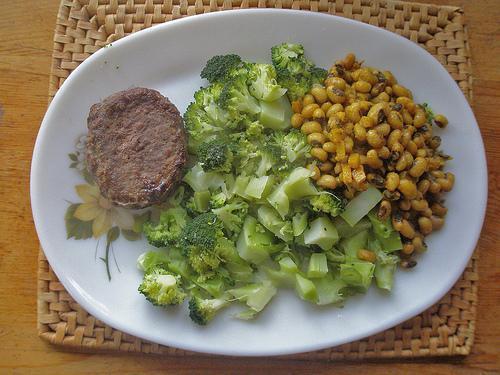How many types of veggie?
Give a very brief answer. 2. 